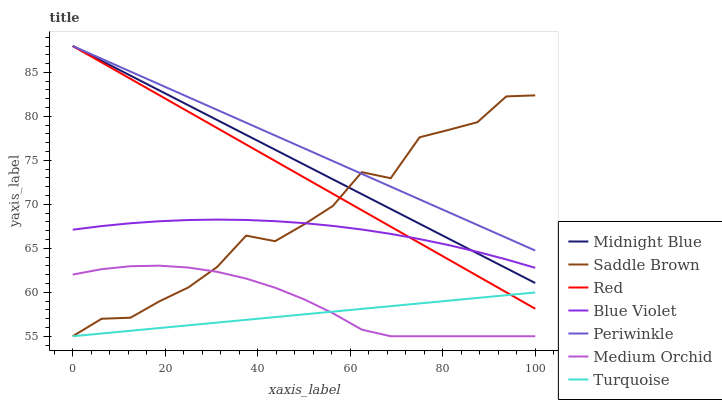Does Turquoise have the minimum area under the curve?
Answer yes or no. Yes. Does Periwinkle have the maximum area under the curve?
Answer yes or no. Yes. Does Midnight Blue have the minimum area under the curve?
Answer yes or no. No. Does Midnight Blue have the maximum area under the curve?
Answer yes or no. No. Is Turquoise the smoothest?
Answer yes or no. Yes. Is Saddle Brown the roughest?
Answer yes or no. Yes. Is Midnight Blue the smoothest?
Answer yes or no. No. Is Midnight Blue the roughest?
Answer yes or no. No. Does Turquoise have the lowest value?
Answer yes or no. Yes. Does Midnight Blue have the lowest value?
Answer yes or no. No. Does Red have the highest value?
Answer yes or no. Yes. Does Medium Orchid have the highest value?
Answer yes or no. No. Is Medium Orchid less than Midnight Blue?
Answer yes or no. Yes. Is Midnight Blue greater than Turquoise?
Answer yes or no. Yes. Does Periwinkle intersect Red?
Answer yes or no. Yes. Is Periwinkle less than Red?
Answer yes or no. No. Is Periwinkle greater than Red?
Answer yes or no. No. Does Medium Orchid intersect Midnight Blue?
Answer yes or no. No. 